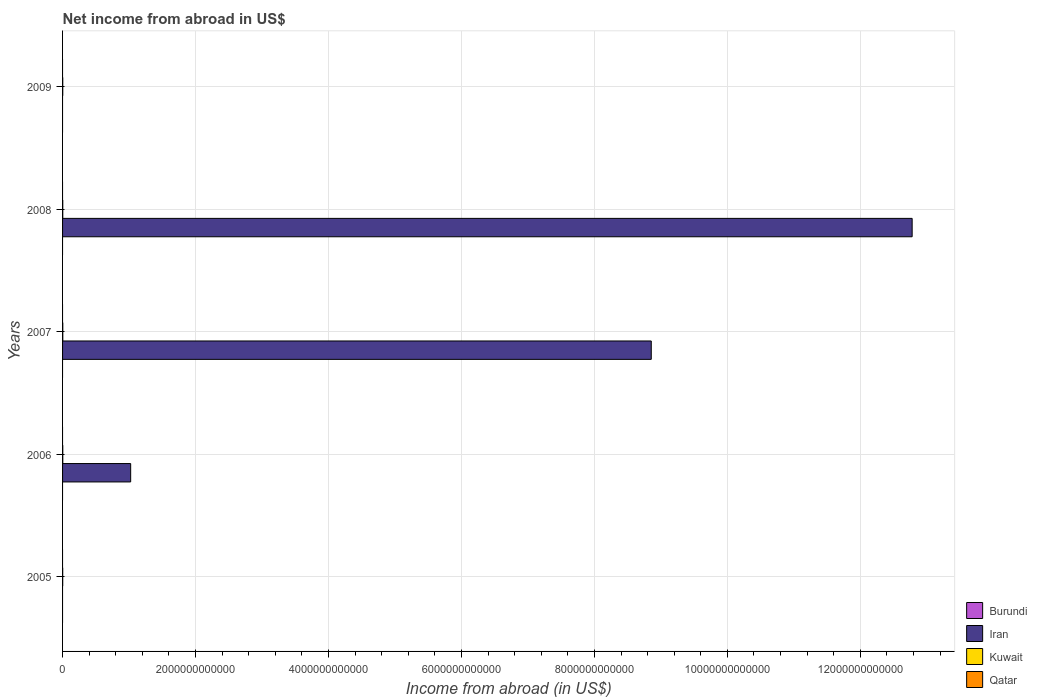In how many cases, is the number of bars for a given year not equal to the number of legend labels?
Offer a very short reply. 5. Across all years, what is the maximum net income from abroad in Iran?
Your answer should be compact. 1.28e+13. Across all years, what is the minimum net income from abroad in Iran?
Ensure brevity in your answer.  0. What is the total net income from abroad in Kuwait in the graph?
Ensure brevity in your answer.  1.44e+1. What is the difference between the net income from abroad in Kuwait in 2005 and that in 2009?
Provide a short and direct response. -6.03e+08. What is the difference between the net income from abroad in Qatar in 2005 and the net income from abroad in Burundi in 2007?
Give a very brief answer. 0. What is the average net income from abroad in Burundi per year?
Your response must be concise. 0. In the year 2006, what is the difference between the net income from abroad in Iran and net income from abroad in Kuwait?
Keep it short and to the point. 1.02e+12. What is the ratio of the net income from abroad in Kuwait in 2006 to that in 2009?
Your answer should be compact. 1.18. Is the net income from abroad in Kuwait in 2007 less than that in 2009?
Provide a succinct answer. No. What is the difference between the highest and the second highest net income from abroad in Kuwait?
Your answer should be very brief. 3.41e+08. What is the difference between the highest and the lowest net income from abroad in Kuwait?
Make the answer very short. 1.43e+09. How many bars are there?
Provide a short and direct response. 8. What is the difference between two consecutive major ticks on the X-axis?
Offer a terse response. 2.00e+12. Does the graph contain any zero values?
Your response must be concise. Yes. Where does the legend appear in the graph?
Make the answer very short. Bottom right. How many legend labels are there?
Ensure brevity in your answer.  4. What is the title of the graph?
Keep it short and to the point. Net income from abroad in US$. Does "Macao" appear as one of the legend labels in the graph?
Make the answer very short. No. What is the label or title of the X-axis?
Offer a terse response. Income from abroad (in US$). What is the label or title of the Y-axis?
Provide a short and direct response. Years. What is the Income from abroad (in US$) in Burundi in 2005?
Offer a terse response. 0. What is the Income from abroad (in US$) in Iran in 2005?
Ensure brevity in your answer.  0. What is the Income from abroad (in US$) of Kuwait in 2005?
Offer a terse response. 2.10e+09. What is the Income from abroad (in US$) in Qatar in 2005?
Keep it short and to the point. 0. What is the Income from abroad (in US$) in Iran in 2006?
Give a very brief answer. 1.02e+12. What is the Income from abroad (in US$) of Kuwait in 2006?
Give a very brief answer. 3.18e+09. What is the Income from abroad (in US$) in Qatar in 2006?
Make the answer very short. 0. What is the Income from abroad (in US$) of Burundi in 2007?
Give a very brief answer. 0. What is the Income from abroad (in US$) in Iran in 2007?
Give a very brief answer. 8.86e+12. What is the Income from abroad (in US$) of Kuwait in 2007?
Offer a terse response. 3.52e+09. What is the Income from abroad (in US$) in Qatar in 2007?
Your answer should be compact. 0. What is the Income from abroad (in US$) of Burundi in 2008?
Provide a short and direct response. 0. What is the Income from abroad (in US$) in Iran in 2008?
Your answer should be very brief. 1.28e+13. What is the Income from abroad (in US$) of Kuwait in 2008?
Offer a very short reply. 2.89e+09. What is the Income from abroad (in US$) in Qatar in 2008?
Your answer should be compact. 0. What is the Income from abroad (in US$) in Burundi in 2009?
Offer a terse response. 0. What is the Income from abroad (in US$) in Iran in 2009?
Your answer should be compact. 0. What is the Income from abroad (in US$) in Kuwait in 2009?
Keep it short and to the point. 2.70e+09. Across all years, what is the maximum Income from abroad (in US$) of Iran?
Your answer should be very brief. 1.28e+13. Across all years, what is the maximum Income from abroad (in US$) in Kuwait?
Ensure brevity in your answer.  3.52e+09. Across all years, what is the minimum Income from abroad (in US$) in Kuwait?
Keep it short and to the point. 2.10e+09. What is the total Income from abroad (in US$) in Iran in the graph?
Offer a very short reply. 2.27e+13. What is the total Income from abroad (in US$) in Kuwait in the graph?
Provide a succinct answer. 1.44e+1. What is the difference between the Income from abroad (in US$) in Kuwait in 2005 and that in 2006?
Provide a short and direct response. -1.08e+09. What is the difference between the Income from abroad (in US$) in Kuwait in 2005 and that in 2007?
Your response must be concise. -1.43e+09. What is the difference between the Income from abroad (in US$) of Kuwait in 2005 and that in 2008?
Your answer should be very brief. -7.91e+08. What is the difference between the Income from abroad (in US$) of Kuwait in 2005 and that in 2009?
Your response must be concise. -6.03e+08. What is the difference between the Income from abroad (in US$) of Iran in 2006 and that in 2007?
Keep it short and to the point. -7.83e+12. What is the difference between the Income from abroad (in US$) of Kuwait in 2006 and that in 2007?
Offer a very short reply. -3.41e+08. What is the difference between the Income from abroad (in US$) of Iran in 2006 and that in 2008?
Ensure brevity in your answer.  -1.18e+13. What is the difference between the Income from abroad (in US$) of Kuwait in 2006 and that in 2008?
Offer a very short reply. 2.94e+08. What is the difference between the Income from abroad (in US$) of Kuwait in 2006 and that in 2009?
Ensure brevity in your answer.  4.82e+08. What is the difference between the Income from abroad (in US$) of Iran in 2007 and that in 2008?
Make the answer very short. -3.92e+12. What is the difference between the Income from abroad (in US$) of Kuwait in 2007 and that in 2008?
Provide a short and direct response. 6.35e+08. What is the difference between the Income from abroad (in US$) of Kuwait in 2007 and that in 2009?
Ensure brevity in your answer.  8.23e+08. What is the difference between the Income from abroad (in US$) of Kuwait in 2008 and that in 2009?
Your answer should be very brief. 1.88e+08. What is the difference between the Income from abroad (in US$) in Iran in 2006 and the Income from abroad (in US$) in Kuwait in 2007?
Keep it short and to the point. 1.02e+12. What is the difference between the Income from abroad (in US$) of Iran in 2006 and the Income from abroad (in US$) of Kuwait in 2008?
Your answer should be very brief. 1.02e+12. What is the difference between the Income from abroad (in US$) of Iran in 2006 and the Income from abroad (in US$) of Kuwait in 2009?
Provide a short and direct response. 1.02e+12. What is the difference between the Income from abroad (in US$) in Iran in 2007 and the Income from abroad (in US$) in Kuwait in 2008?
Ensure brevity in your answer.  8.85e+12. What is the difference between the Income from abroad (in US$) in Iran in 2007 and the Income from abroad (in US$) in Kuwait in 2009?
Offer a very short reply. 8.85e+12. What is the difference between the Income from abroad (in US$) in Iran in 2008 and the Income from abroad (in US$) in Kuwait in 2009?
Your answer should be very brief. 1.28e+13. What is the average Income from abroad (in US$) in Burundi per year?
Ensure brevity in your answer.  0. What is the average Income from abroad (in US$) of Iran per year?
Give a very brief answer. 4.53e+12. What is the average Income from abroad (in US$) in Kuwait per year?
Offer a very short reply. 2.88e+09. In the year 2006, what is the difference between the Income from abroad (in US$) in Iran and Income from abroad (in US$) in Kuwait?
Ensure brevity in your answer.  1.02e+12. In the year 2007, what is the difference between the Income from abroad (in US$) of Iran and Income from abroad (in US$) of Kuwait?
Your answer should be compact. 8.85e+12. In the year 2008, what is the difference between the Income from abroad (in US$) of Iran and Income from abroad (in US$) of Kuwait?
Give a very brief answer. 1.28e+13. What is the ratio of the Income from abroad (in US$) of Kuwait in 2005 to that in 2006?
Your answer should be very brief. 0.66. What is the ratio of the Income from abroad (in US$) of Kuwait in 2005 to that in 2007?
Offer a very short reply. 0.6. What is the ratio of the Income from abroad (in US$) of Kuwait in 2005 to that in 2008?
Your response must be concise. 0.73. What is the ratio of the Income from abroad (in US$) in Kuwait in 2005 to that in 2009?
Your answer should be very brief. 0.78. What is the ratio of the Income from abroad (in US$) in Iran in 2006 to that in 2007?
Your answer should be compact. 0.12. What is the ratio of the Income from abroad (in US$) in Kuwait in 2006 to that in 2007?
Offer a terse response. 0.9. What is the ratio of the Income from abroad (in US$) in Iran in 2006 to that in 2008?
Your response must be concise. 0.08. What is the ratio of the Income from abroad (in US$) in Kuwait in 2006 to that in 2008?
Offer a very short reply. 1.1. What is the ratio of the Income from abroad (in US$) in Kuwait in 2006 to that in 2009?
Give a very brief answer. 1.18. What is the ratio of the Income from abroad (in US$) of Iran in 2007 to that in 2008?
Give a very brief answer. 0.69. What is the ratio of the Income from abroad (in US$) in Kuwait in 2007 to that in 2008?
Keep it short and to the point. 1.22. What is the ratio of the Income from abroad (in US$) of Kuwait in 2007 to that in 2009?
Ensure brevity in your answer.  1.3. What is the ratio of the Income from abroad (in US$) in Kuwait in 2008 to that in 2009?
Keep it short and to the point. 1.07. What is the difference between the highest and the second highest Income from abroad (in US$) of Iran?
Provide a succinct answer. 3.92e+12. What is the difference between the highest and the second highest Income from abroad (in US$) in Kuwait?
Provide a short and direct response. 3.41e+08. What is the difference between the highest and the lowest Income from abroad (in US$) of Iran?
Keep it short and to the point. 1.28e+13. What is the difference between the highest and the lowest Income from abroad (in US$) in Kuwait?
Your response must be concise. 1.43e+09. 